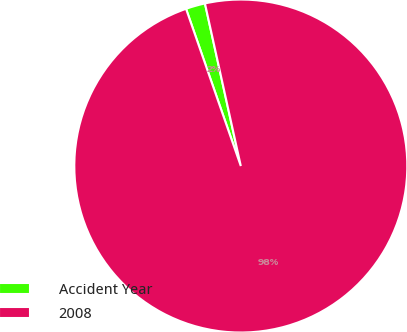Convert chart to OTSL. <chart><loc_0><loc_0><loc_500><loc_500><pie_chart><fcel>Accident Year<fcel>2008<nl><fcel>1.88%<fcel>98.12%<nl></chart> 